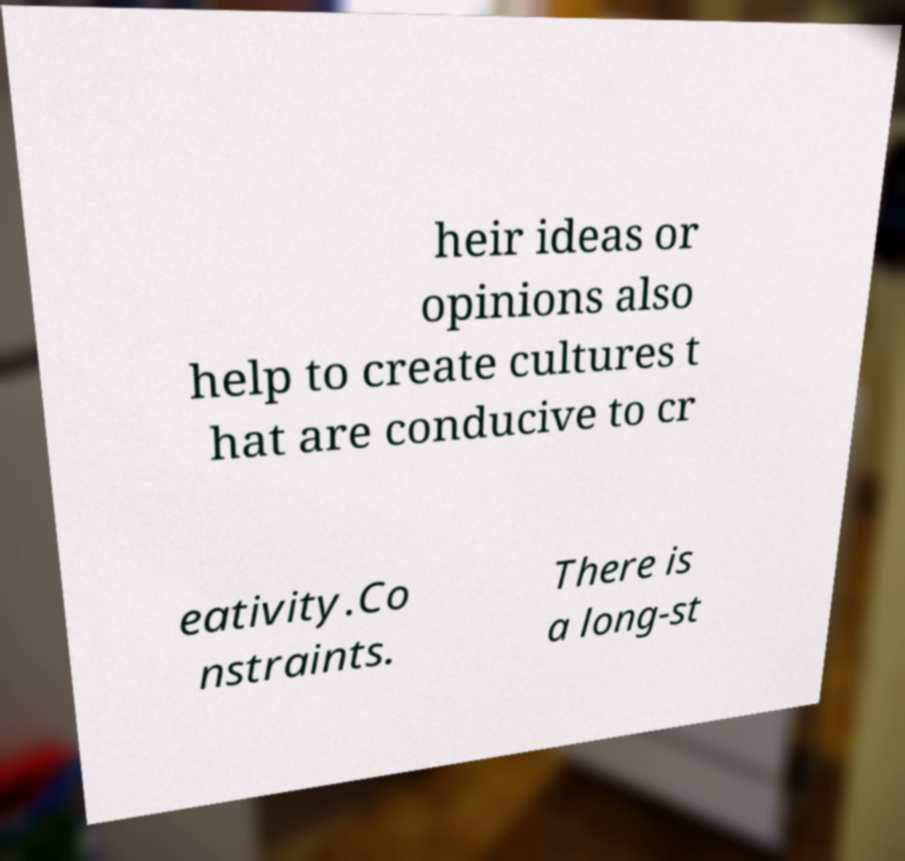Can you accurately transcribe the text from the provided image for me? heir ideas or opinions also help to create cultures t hat are conducive to cr eativity.Co nstraints. There is a long-st 